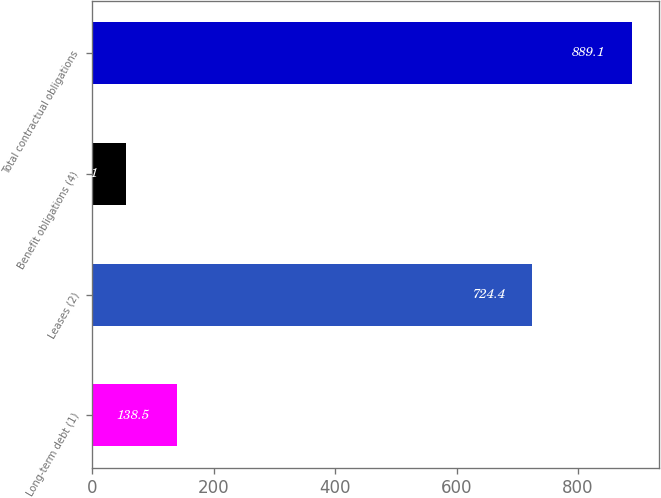Convert chart. <chart><loc_0><loc_0><loc_500><loc_500><bar_chart><fcel>Long-term debt (1)<fcel>Leases (2)<fcel>Benefit obligations (4)<fcel>Total contractual obligations<nl><fcel>138.5<fcel>724.4<fcel>55.1<fcel>889.1<nl></chart> 